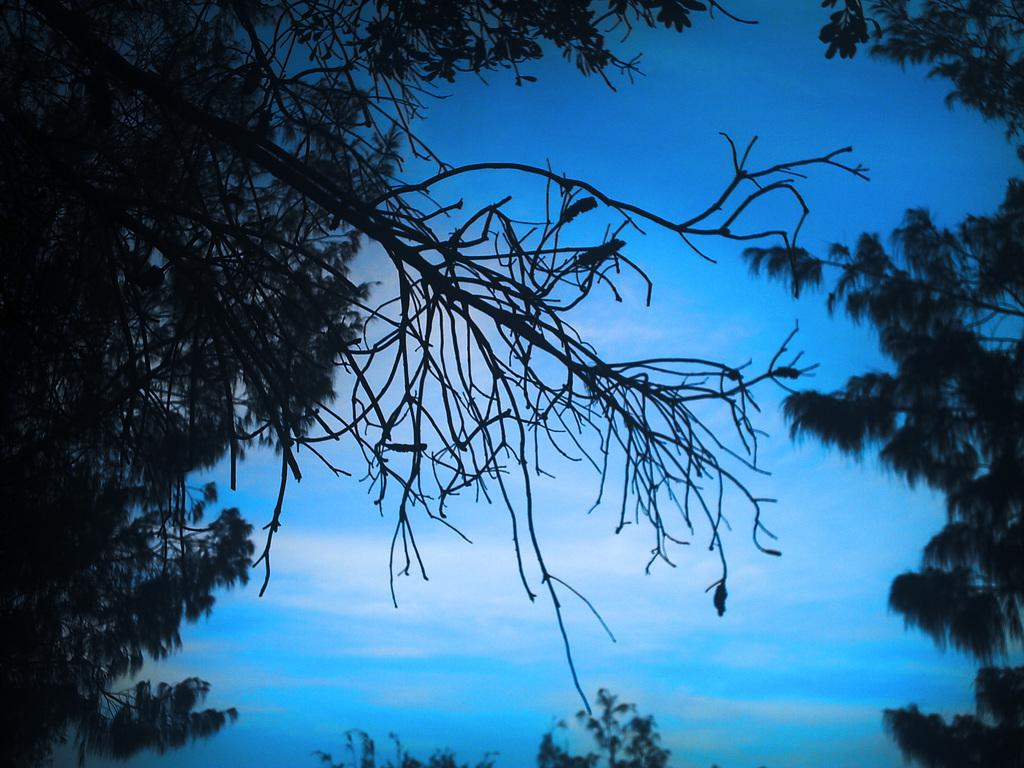What type of vegetation can be seen in the image? There are trees in the image. What part of the natural environment is visible in the image? The sky is visible in the background of the image. What color is the orange door in the image? There is no orange door present in the image. What type of teeth can be seen in the image? There are no teeth visible in the image. 